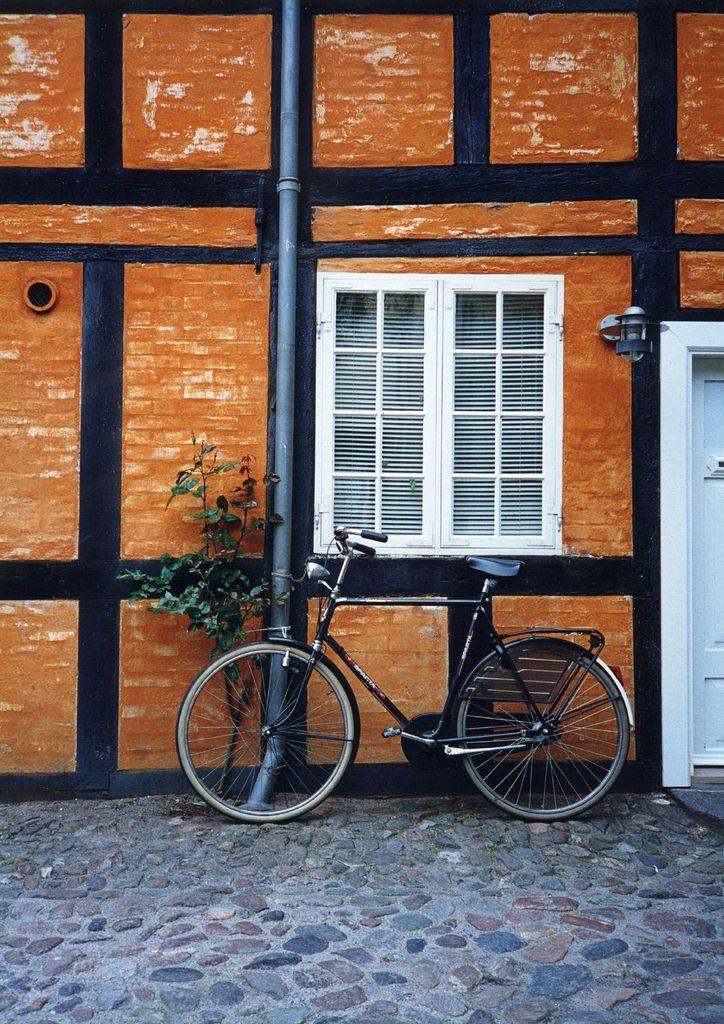What is the main object in the image? There is a bicycle in the image. What other object is present in the image? There is a plant in the image. Where are the bicycle and plant located in the image? The bicycle and plant are at the bottom of the image. What can be seen in the background of the image? There is a wall in the background of the image. What architectural features are present in the middle of the image? There is a window, pipe, and door in the middle of the image. What type of drawer can be seen in the image? There is no drawer present in the image. How old is the boy in the image? There is no boy present in the image. 